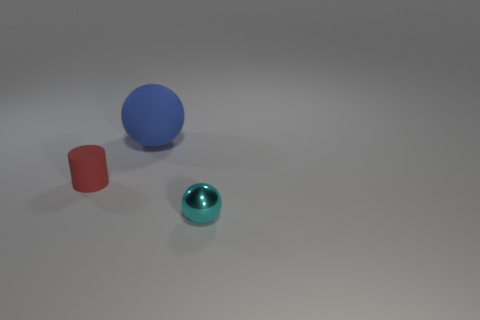Add 2 tiny cyan metallic balls. How many objects exist? 5 Subtract all spheres. How many objects are left? 1 Subtract 0 blue cylinders. How many objects are left? 3 Subtract all small red rubber cylinders. Subtract all small matte cylinders. How many objects are left? 1 Add 2 large blue balls. How many large blue balls are left? 3 Add 2 brown blocks. How many brown blocks exist? 2 